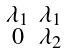Convert formula to latex. <formula><loc_0><loc_0><loc_500><loc_500>\begin{smallmatrix} \lambda _ { 1 } & \lambda _ { 1 } \\ 0 & \lambda _ { 2 } & \end{smallmatrix}</formula> 